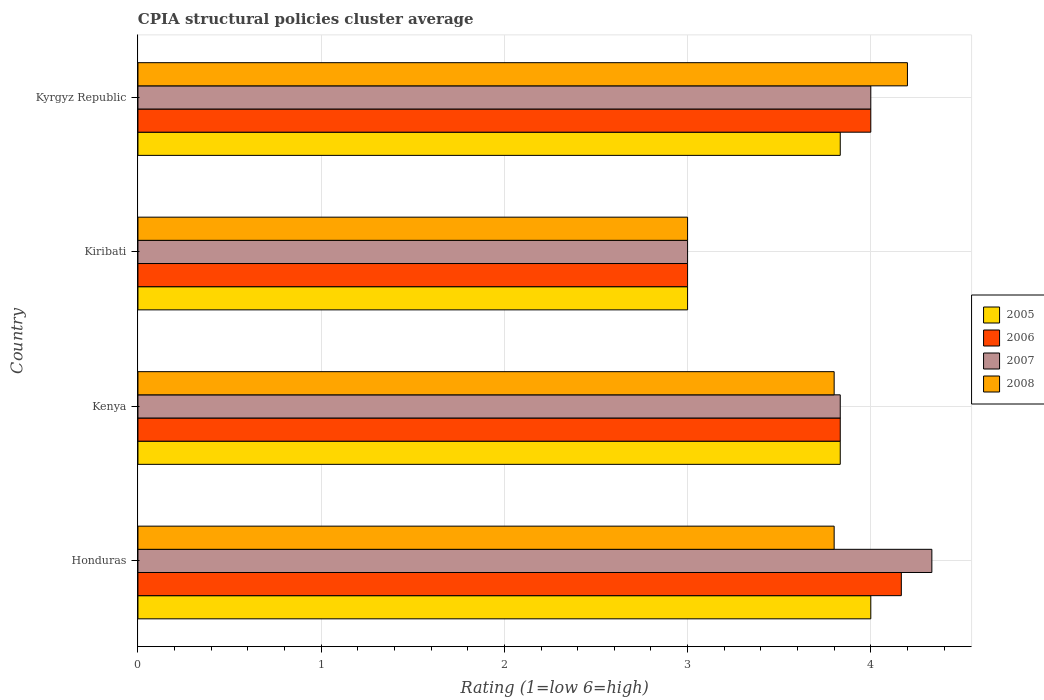How many groups of bars are there?
Provide a short and direct response. 4. How many bars are there on the 2nd tick from the top?
Offer a very short reply. 4. What is the label of the 4th group of bars from the top?
Provide a short and direct response. Honduras. In which country was the CPIA rating in 2008 maximum?
Provide a short and direct response. Kyrgyz Republic. In which country was the CPIA rating in 2006 minimum?
Give a very brief answer. Kiribati. What is the total CPIA rating in 2005 in the graph?
Offer a terse response. 14.67. What is the difference between the CPIA rating in 2007 in Honduras and that in Kiribati?
Offer a very short reply. 1.33. What is the difference between the CPIA rating in 2007 in Kenya and the CPIA rating in 2005 in Kiribati?
Offer a very short reply. 0.83. What is the average CPIA rating in 2007 per country?
Make the answer very short. 3.79. What is the difference between the CPIA rating in 2006 and CPIA rating in 2007 in Kenya?
Your answer should be very brief. 0. In how many countries, is the CPIA rating in 2006 greater than 3.6 ?
Offer a very short reply. 3. What is the ratio of the CPIA rating in 2005 in Honduras to that in Kiribati?
Provide a succinct answer. 1.33. Is the CPIA rating in 2006 in Honduras less than that in Kenya?
Your response must be concise. No. Is the difference between the CPIA rating in 2006 in Kiribati and Kyrgyz Republic greater than the difference between the CPIA rating in 2007 in Kiribati and Kyrgyz Republic?
Offer a terse response. No. What is the difference between the highest and the second highest CPIA rating in 2008?
Your answer should be compact. 0.4. What is the difference between the highest and the lowest CPIA rating in 2008?
Provide a succinct answer. 1.2. Is the sum of the CPIA rating in 2008 in Honduras and Kenya greater than the maximum CPIA rating in 2006 across all countries?
Provide a short and direct response. Yes. Is it the case that in every country, the sum of the CPIA rating in 2006 and CPIA rating in 2008 is greater than the sum of CPIA rating in 2005 and CPIA rating in 2007?
Provide a short and direct response. No. What does the 2nd bar from the top in Kyrgyz Republic represents?
Your response must be concise. 2007. How many bars are there?
Offer a terse response. 16. Are all the bars in the graph horizontal?
Ensure brevity in your answer.  Yes. Does the graph contain any zero values?
Your answer should be very brief. No. Does the graph contain grids?
Make the answer very short. Yes. How many legend labels are there?
Keep it short and to the point. 4. How are the legend labels stacked?
Offer a very short reply. Vertical. What is the title of the graph?
Keep it short and to the point. CPIA structural policies cluster average. What is the Rating (1=low 6=high) in 2006 in Honduras?
Provide a short and direct response. 4.17. What is the Rating (1=low 6=high) of 2007 in Honduras?
Offer a very short reply. 4.33. What is the Rating (1=low 6=high) in 2008 in Honduras?
Your answer should be very brief. 3.8. What is the Rating (1=low 6=high) of 2005 in Kenya?
Your answer should be very brief. 3.83. What is the Rating (1=low 6=high) of 2006 in Kenya?
Offer a very short reply. 3.83. What is the Rating (1=low 6=high) in 2007 in Kenya?
Offer a terse response. 3.83. What is the Rating (1=low 6=high) of 2007 in Kiribati?
Ensure brevity in your answer.  3. What is the Rating (1=low 6=high) of 2008 in Kiribati?
Your answer should be compact. 3. What is the Rating (1=low 6=high) in 2005 in Kyrgyz Republic?
Ensure brevity in your answer.  3.83. What is the Rating (1=low 6=high) in 2006 in Kyrgyz Republic?
Keep it short and to the point. 4. What is the Rating (1=low 6=high) in 2008 in Kyrgyz Republic?
Your answer should be compact. 4.2. Across all countries, what is the maximum Rating (1=low 6=high) in 2005?
Your response must be concise. 4. Across all countries, what is the maximum Rating (1=low 6=high) of 2006?
Keep it short and to the point. 4.17. Across all countries, what is the maximum Rating (1=low 6=high) in 2007?
Offer a very short reply. 4.33. Across all countries, what is the maximum Rating (1=low 6=high) in 2008?
Your answer should be compact. 4.2. Across all countries, what is the minimum Rating (1=low 6=high) in 2005?
Offer a terse response. 3. Across all countries, what is the minimum Rating (1=low 6=high) in 2006?
Your answer should be compact. 3. What is the total Rating (1=low 6=high) in 2005 in the graph?
Offer a terse response. 14.67. What is the total Rating (1=low 6=high) of 2007 in the graph?
Offer a terse response. 15.17. What is the difference between the Rating (1=low 6=high) in 2006 in Honduras and that in Kenya?
Your answer should be compact. 0.33. What is the difference between the Rating (1=low 6=high) in 2008 in Honduras and that in Kiribati?
Your answer should be compact. 0.8. What is the difference between the Rating (1=low 6=high) in 2005 in Honduras and that in Kyrgyz Republic?
Your response must be concise. 0.17. What is the difference between the Rating (1=low 6=high) in 2006 in Honduras and that in Kyrgyz Republic?
Give a very brief answer. 0.17. What is the difference between the Rating (1=low 6=high) of 2008 in Honduras and that in Kyrgyz Republic?
Offer a terse response. -0.4. What is the difference between the Rating (1=low 6=high) of 2007 in Kenya and that in Kiribati?
Your answer should be very brief. 0.83. What is the difference between the Rating (1=low 6=high) of 2007 in Kenya and that in Kyrgyz Republic?
Ensure brevity in your answer.  -0.17. What is the difference between the Rating (1=low 6=high) of 2008 in Kenya and that in Kyrgyz Republic?
Your answer should be compact. -0.4. What is the difference between the Rating (1=low 6=high) in 2005 in Kiribati and that in Kyrgyz Republic?
Provide a succinct answer. -0.83. What is the difference between the Rating (1=low 6=high) of 2007 in Kiribati and that in Kyrgyz Republic?
Your answer should be very brief. -1. What is the difference between the Rating (1=low 6=high) of 2005 in Honduras and the Rating (1=low 6=high) of 2006 in Kenya?
Provide a short and direct response. 0.17. What is the difference between the Rating (1=low 6=high) of 2005 in Honduras and the Rating (1=low 6=high) of 2008 in Kenya?
Make the answer very short. 0.2. What is the difference between the Rating (1=low 6=high) of 2006 in Honduras and the Rating (1=low 6=high) of 2007 in Kenya?
Your answer should be very brief. 0.33. What is the difference between the Rating (1=low 6=high) of 2006 in Honduras and the Rating (1=low 6=high) of 2008 in Kenya?
Your answer should be compact. 0.37. What is the difference between the Rating (1=low 6=high) of 2007 in Honduras and the Rating (1=low 6=high) of 2008 in Kenya?
Give a very brief answer. 0.53. What is the difference between the Rating (1=low 6=high) of 2005 in Honduras and the Rating (1=low 6=high) of 2006 in Kyrgyz Republic?
Keep it short and to the point. 0. What is the difference between the Rating (1=low 6=high) of 2005 in Honduras and the Rating (1=low 6=high) of 2008 in Kyrgyz Republic?
Provide a short and direct response. -0.2. What is the difference between the Rating (1=low 6=high) of 2006 in Honduras and the Rating (1=low 6=high) of 2008 in Kyrgyz Republic?
Your response must be concise. -0.03. What is the difference between the Rating (1=low 6=high) in 2007 in Honduras and the Rating (1=low 6=high) in 2008 in Kyrgyz Republic?
Provide a short and direct response. 0.13. What is the difference between the Rating (1=low 6=high) in 2005 in Kenya and the Rating (1=low 6=high) in 2007 in Kiribati?
Offer a very short reply. 0.83. What is the difference between the Rating (1=low 6=high) of 2005 in Kenya and the Rating (1=low 6=high) of 2008 in Kiribati?
Offer a terse response. 0.83. What is the difference between the Rating (1=low 6=high) in 2006 in Kenya and the Rating (1=low 6=high) in 2007 in Kiribati?
Your answer should be very brief. 0.83. What is the difference between the Rating (1=low 6=high) in 2005 in Kenya and the Rating (1=low 6=high) in 2006 in Kyrgyz Republic?
Make the answer very short. -0.17. What is the difference between the Rating (1=low 6=high) in 2005 in Kenya and the Rating (1=low 6=high) in 2008 in Kyrgyz Republic?
Offer a very short reply. -0.37. What is the difference between the Rating (1=low 6=high) in 2006 in Kenya and the Rating (1=low 6=high) in 2008 in Kyrgyz Republic?
Your answer should be compact. -0.37. What is the difference between the Rating (1=low 6=high) in 2007 in Kenya and the Rating (1=low 6=high) in 2008 in Kyrgyz Republic?
Your response must be concise. -0.37. What is the difference between the Rating (1=low 6=high) in 2005 in Kiribati and the Rating (1=low 6=high) in 2006 in Kyrgyz Republic?
Keep it short and to the point. -1. What is the difference between the Rating (1=low 6=high) in 2006 in Kiribati and the Rating (1=low 6=high) in 2007 in Kyrgyz Republic?
Give a very brief answer. -1. What is the difference between the Rating (1=low 6=high) of 2007 in Kiribati and the Rating (1=low 6=high) of 2008 in Kyrgyz Republic?
Your response must be concise. -1.2. What is the average Rating (1=low 6=high) of 2005 per country?
Make the answer very short. 3.67. What is the average Rating (1=low 6=high) in 2006 per country?
Make the answer very short. 3.75. What is the average Rating (1=low 6=high) of 2007 per country?
Make the answer very short. 3.79. What is the average Rating (1=low 6=high) in 2008 per country?
Your response must be concise. 3.7. What is the difference between the Rating (1=low 6=high) in 2005 and Rating (1=low 6=high) in 2007 in Honduras?
Your response must be concise. -0.33. What is the difference between the Rating (1=low 6=high) of 2005 and Rating (1=low 6=high) of 2008 in Honduras?
Keep it short and to the point. 0.2. What is the difference between the Rating (1=low 6=high) of 2006 and Rating (1=low 6=high) of 2007 in Honduras?
Provide a short and direct response. -0.17. What is the difference between the Rating (1=low 6=high) in 2006 and Rating (1=low 6=high) in 2008 in Honduras?
Your answer should be compact. 0.37. What is the difference between the Rating (1=low 6=high) of 2007 and Rating (1=low 6=high) of 2008 in Honduras?
Give a very brief answer. 0.53. What is the difference between the Rating (1=low 6=high) of 2006 and Rating (1=low 6=high) of 2008 in Kenya?
Ensure brevity in your answer.  0.03. What is the difference between the Rating (1=low 6=high) in 2005 and Rating (1=low 6=high) in 2006 in Kiribati?
Make the answer very short. 0. What is the difference between the Rating (1=low 6=high) in 2006 and Rating (1=low 6=high) in 2008 in Kiribati?
Give a very brief answer. 0. What is the difference between the Rating (1=low 6=high) in 2007 and Rating (1=low 6=high) in 2008 in Kiribati?
Provide a succinct answer. 0. What is the difference between the Rating (1=low 6=high) in 2005 and Rating (1=low 6=high) in 2008 in Kyrgyz Republic?
Your answer should be compact. -0.37. What is the difference between the Rating (1=low 6=high) in 2006 and Rating (1=low 6=high) in 2007 in Kyrgyz Republic?
Make the answer very short. 0. What is the difference between the Rating (1=low 6=high) of 2007 and Rating (1=low 6=high) of 2008 in Kyrgyz Republic?
Provide a short and direct response. -0.2. What is the ratio of the Rating (1=low 6=high) in 2005 in Honduras to that in Kenya?
Give a very brief answer. 1.04. What is the ratio of the Rating (1=low 6=high) of 2006 in Honduras to that in Kenya?
Give a very brief answer. 1.09. What is the ratio of the Rating (1=low 6=high) in 2007 in Honduras to that in Kenya?
Give a very brief answer. 1.13. What is the ratio of the Rating (1=low 6=high) in 2008 in Honduras to that in Kenya?
Your response must be concise. 1. What is the ratio of the Rating (1=low 6=high) in 2006 in Honduras to that in Kiribati?
Give a very brief answer. 1.39. What is the ratio of the Rating (1=low 6=high) of 2007 in Honduras to that in Kiribati?
Ensure brevity in your answer.  1.44. What is the ratio of the Rating (1=low 6=high) of 2008 in Honduras to that in Kiribati?
Your answer should be very brief. 1.27. What is the ratio of the Rating (1=low 6=high) of 2005 in Honduras to that in Kyrgyz Republic?
Ensure brevity in your answer.  1.04. What is the ratio of the Rating (1=low 6=high) of 2006 in Honduras to that in Kyrgyz Republic?
Your response must be concise. 1.04. What is the ratio of the Rating (1=low 6=high) of 2008 in Honduras to that in Kyrgyz Republic?
Make the answer very short. 0.9. What is the ratio of the Rating (1=low 6=high) of 2005 in Kenya to that in Kiribati?
Your response must be concise. 1.28. What is the ratio of the Rating (1=low 6=high) in 2006 in Kenya to that in Kiribati?
Provide a short and direct response. 1.28. What is the ratio of the Rating (1=low 6=high) in 2007 in Kenya to that in Kiribati?
Keep it short and to the point. 1.28. What is the ratio of the Rating (1=low 6=high) of 2008 in Kenya to that in Kiribati?
Offer a terse response. 1.27. What is the ratio of the Rating (1=low 6=high) in 2006 in Kenya to that in Kyrgyz Republic?
Give a very brief answer. 0.96. What is the ratio of the Rating (1=low 6=high) in 2008 in Kenya to that in Kyrgyz Republic?
Give a very brief answer. 0.9. What is the ratio of the Rating (1=low 6=high) in 2005 in Kiribati to that in Kyrgyz Republic?
Give a very brief answer. 0.78. What is the ratio of the Rating (1=low 6=high) of 2007 in Kiribati to that in Kyrgyz Republic?
Offer a very short reply. 0.75. What is the difference between the highest and the second highest Rating (1=low 6=high) in 2005?
Your answer should be very brief. 0.17. What is the difference between the highest and the second highest Rating (1=low 6=high) of 2006?
Make the answer very short. 0.17. What is the difference between the highest and the second highest Rating (1=low 6=high) in 2007?
Ensure brevity in your answer.  0.33. What is the difference between the highest and the second highest Rating (1=low 6=high) of 2008?
Make the answer very short. 0.4. What is the difference between the highest and the lowest Rating (1=low 6=high) in 2006?
Offer a very short reply. 1.17. 